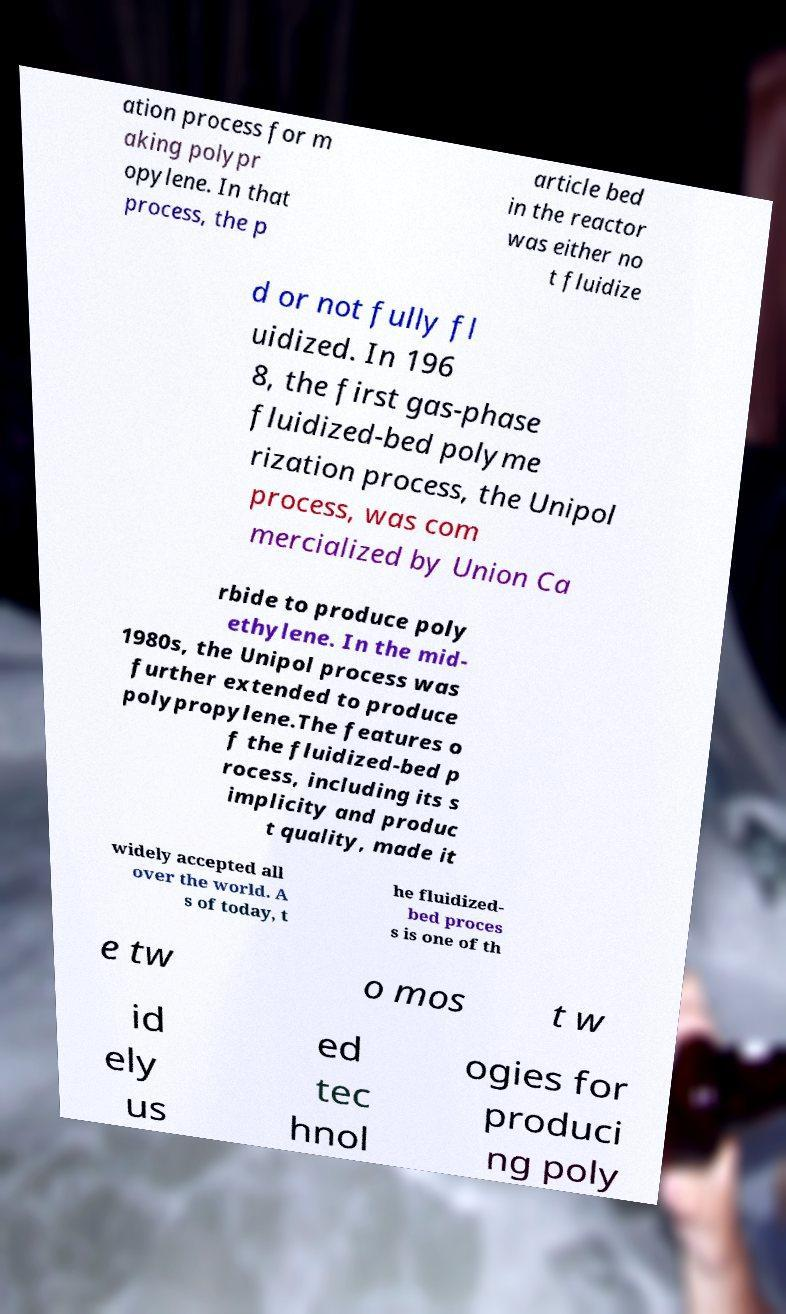Please identify and transcribe the text found in this image. ation process for m aking polypr opylene. In that process, the p article bed in the reactor was either no t fluidize d or not fully fl uidized. In 196 8, the first gas-phase fluidized-bed polyme rization process, the Unipol process, was com mercialized by Union Ca rbide to produce poly ethylene. In the mid- 1980s, the Unipol process was further extended to produce polypropylene.The features o f the fluidized-bed p rocess, including its s implicity and produc t quality, made it widely accepted all over the world. A s of today, t he fluidized- bed proces s is one of th e tw o mos t w id ely us ed tec hnol ogies for produci ng poly 